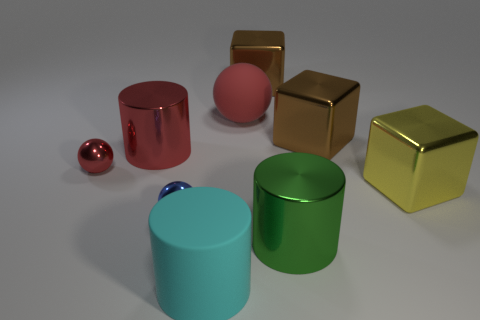Add 1 big gray things. How many objects exist? 10 Subtract all balls. How many objects are left? 6 Subtract all yellow cubes. Subtract all cyan cylinders. How many objects are left? 7 Add 6 large rubber things. How many large rubber things are left? 8 Add 4 large metal things. How many large metal things exist? 9 Subtract 0 green balls. How many objects are left? 9 